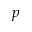<formula> <loc_0><loc_0><loc_500><loc_500>p</formula> 